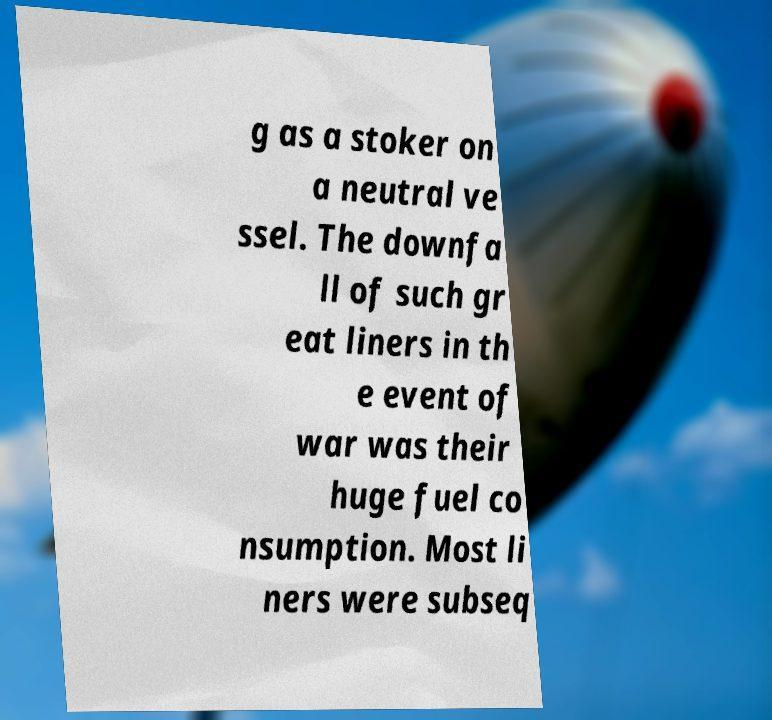Please read and relay the text visible in this image. What does it say? g as a stoker on a neutral ve ssel. The downfa ll of such gr eat liners in th e event of war was their huge fuel co nsumption. Most li ners were subseq 